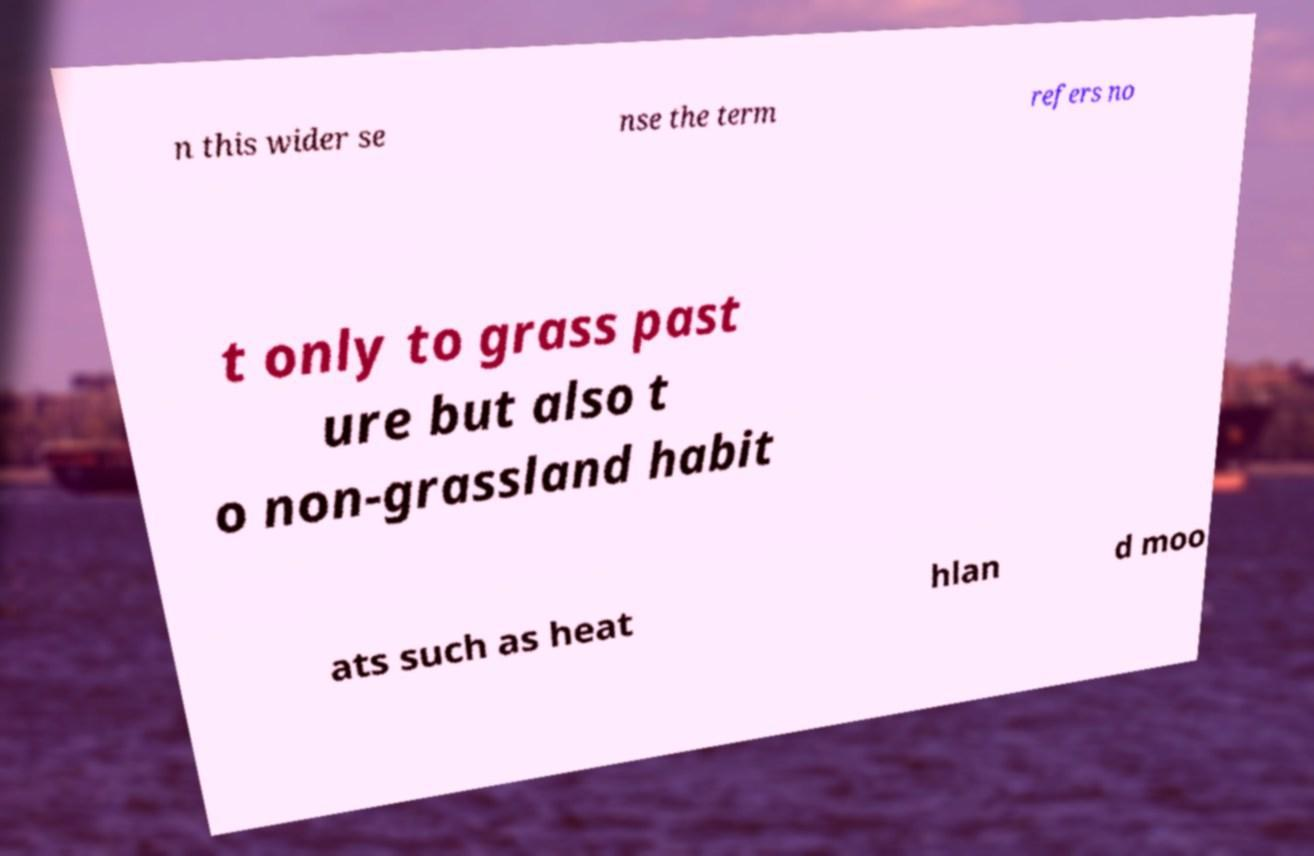There's text embedded in this image that I need extracted. Can you transcribe it verbatim? n this wider se nse the term refers no t only to grass past ure but also t o non-grassland habit ats such as heat hlan d moo 